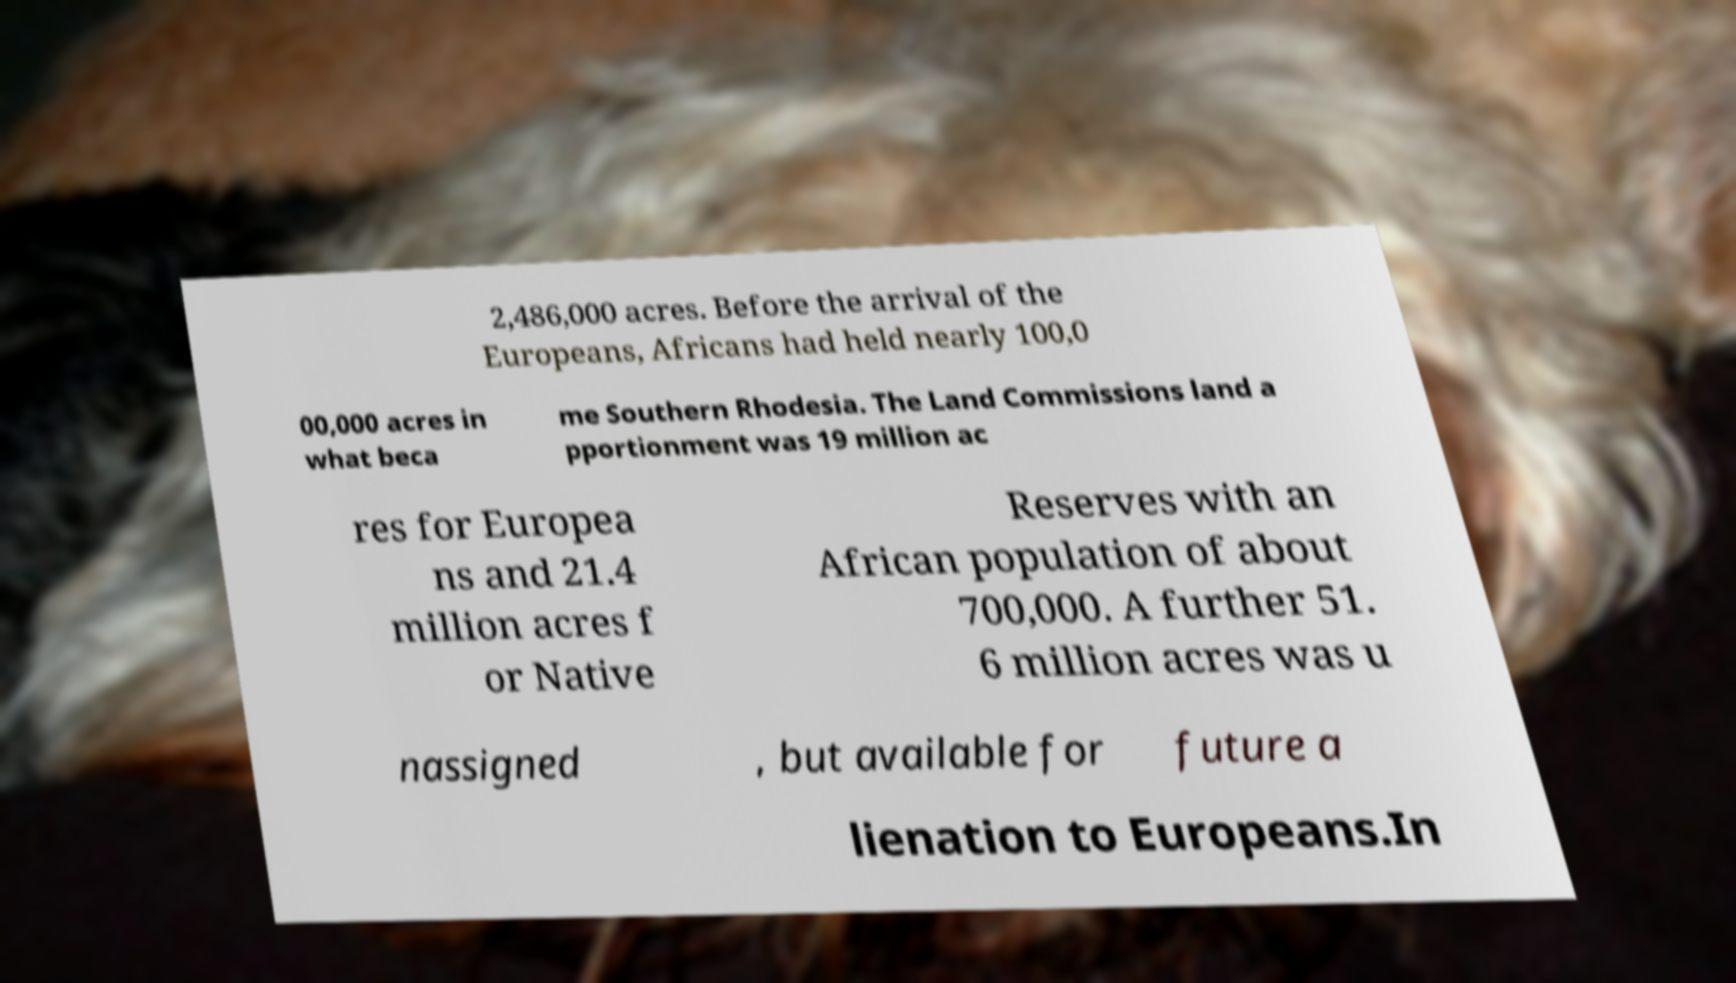I need the written content from this picture converted into text. Can you do that? 2,486,000 acres. Before the arrival of the Europeans, Africans had held nearly 100,0 00,000 acres in what beca me Southern Rhodesia. The Land Commissions land a pportionment was 19 million ac res for Europea ns and 21.4 million acres f or Native Reserves with an African population of about 700,000. A further 51. 6 million acres was u nassigned , but available for future a lienation to Europeans.In 